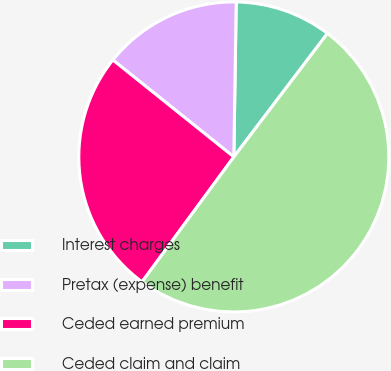Convert chart to OTSL. <chart><loc_0><loc_0><loc_500><loc_500><pie_chart><fcel>Interest charges<fcel>Pretax (expense) benefit<fcel>Ceded earned premium<fcel>Ceded claim and claim<nl><fcel>10.08%<fcel>14.49%<fcel>25.67%<fcel>49.76%<nl></chart> 